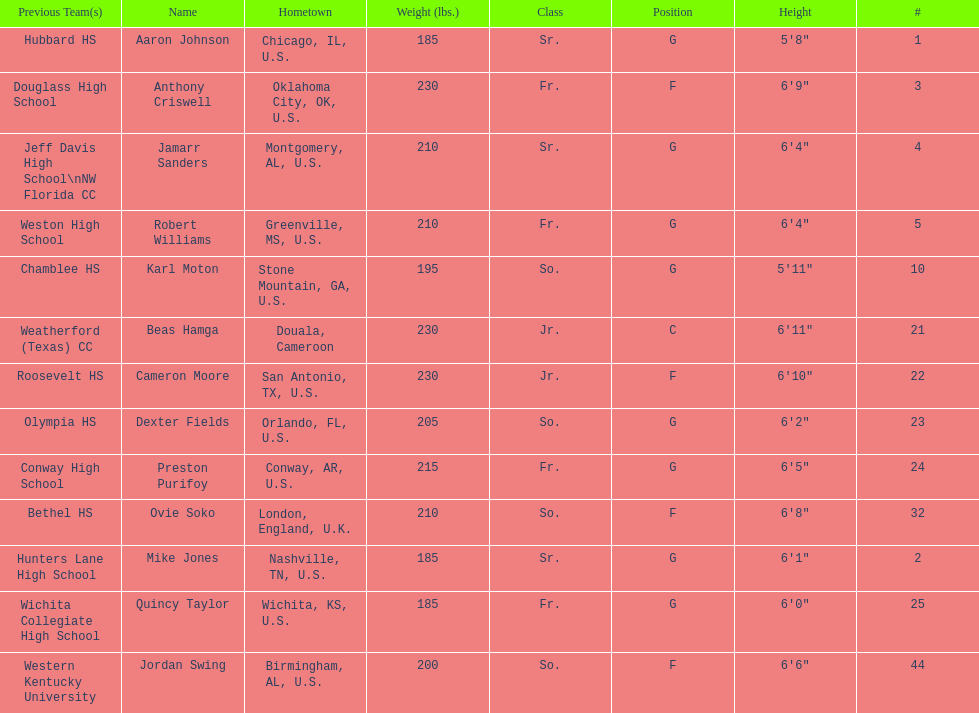How many players were on the 2010-11 uab blazers men's basketball team? 13. 